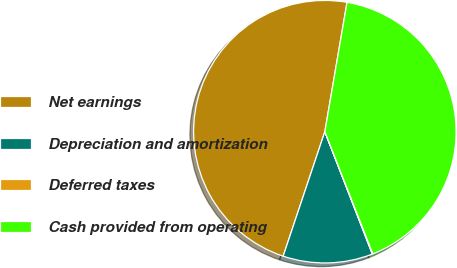Convert chart. <chart><loc_0><loc_0><loc_500><loc_500><pie_chart><fcel>Net earnings<fcel>Depreciation and amortization<fcel>Deferred taxes<fcel>Cash provided from operating<nl><fcel>47.56%<fcel>11.03%<fcel>0.07%<fcel>41.34%<nl></chart> 